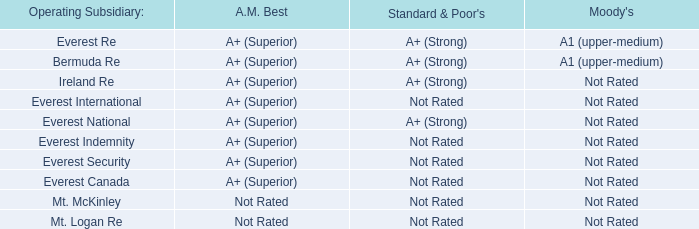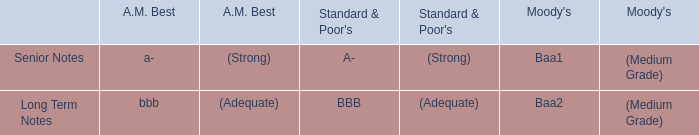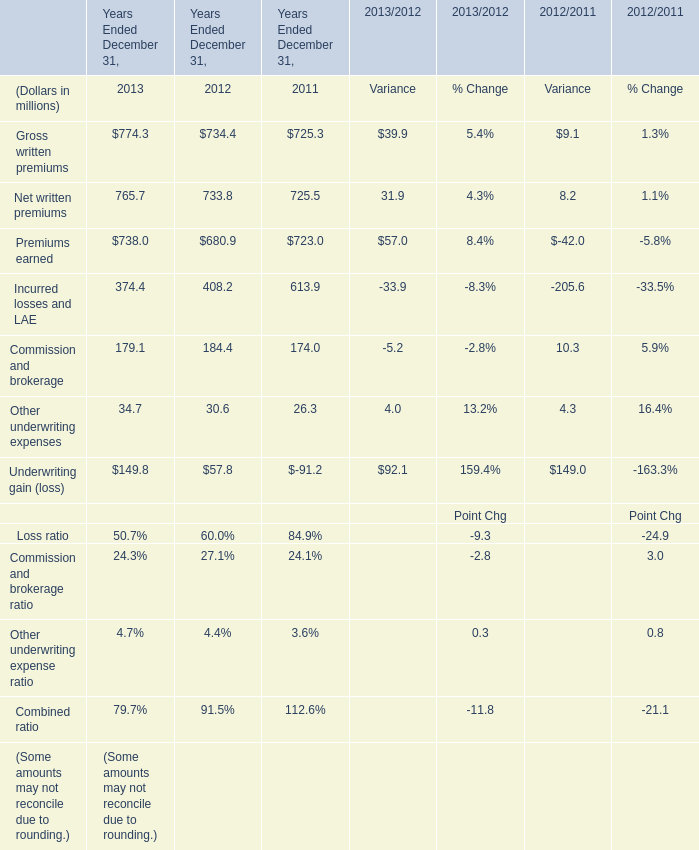What was the sum of Years Ended December 31 without those Years Ended December 31 smaller than 700 in 2013? (in million) 
Computations: ((774.3 + 765.7) + 738.0)
Answer: 2278.0. 